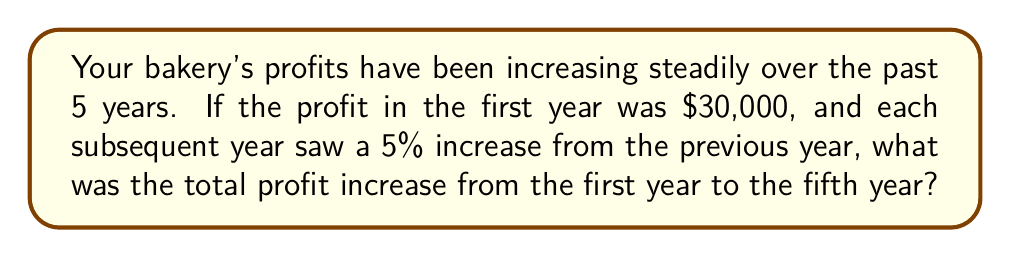Show me your answer to this math problem. Let's calculate this step-by-step:

1) First, let's calculate the profit for each year:

   Year 1: $30,000
   Year 2: $30,000 * 1.05 = $31,500
   Year 3: $31,500 * 1.05 = $33,075
   Year 4: $33,075 * 1.05 = $34,728.75
   Year 5: $34,728.75 * 1.05 = $36,465.19

2) Now, let's calculate the total increase:

   $36,465.19 - $30,000 = $6,465.19

3) We can verify this using the compound interest formula:

   $$A = P(1 + r)^n$$

   Where:
   A = Final amount
   P = Principal amount (initial investment)
   r = Annual interest rate (in decimal form)
   n = Number of years

   $$A = 30000(1 + 0.05)^4 = 36,465.19$$

4) The difference between this and the initial amount is indeed $6,465.19.
Answer: $6,465.19 